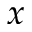Convert formula to latex. <formula><loc_0><loc_0><loc_500><loc_500>x</formula> 